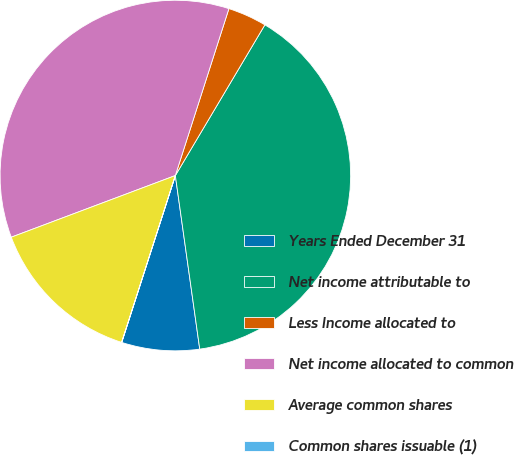<chart> <loc_0><loc_0><loc_500><loc_500><pie_chart><fcel>Years Ended December 31<fcel>Net income attributable to<fcel>Less Income allocated to<fcel>Net income allocated to common<fcel>Average common shares<fcel>Common shares issuable (1)<nl><fcel>7.17%<fcel>39.24%<fcel>3.59%<fcel>35.66%<fcel>14.32%<fcel>0.01%<nl></chart> 